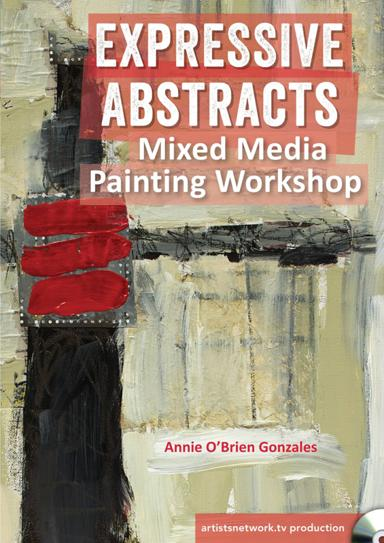What kind of audience would typically be interested in attending this workshop? This workshop is ideally suited for both emerging and established artists who are keen to delve into or expand their capabilities in mixed media and abstract painting. Art students, hobby painters, and professional artists looking to experiment with new styles or seeking fresh inspiration would find this workshop particularly enriching. 